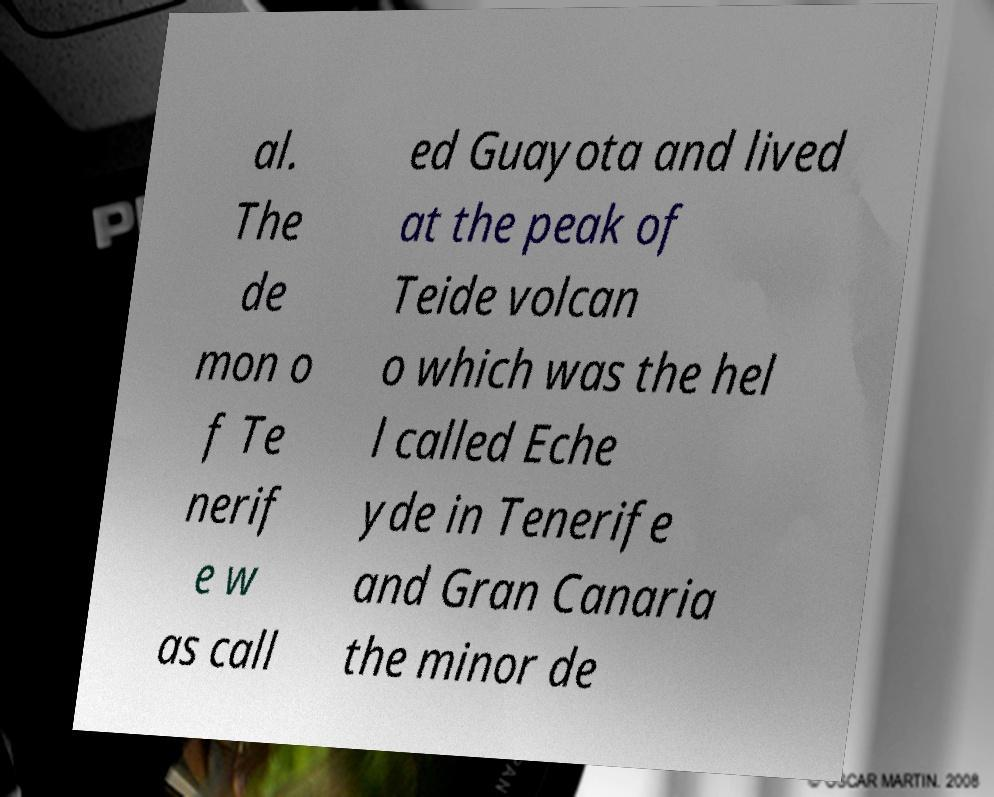Can you accurately transcribe the text from the provided image for me? al. The de mon o f Te nerif e w as call ed Guayota and lived at the peak of Teide volcan o which was the hel l called Eche yde in Tenerife and Gran Canaria the minor de 